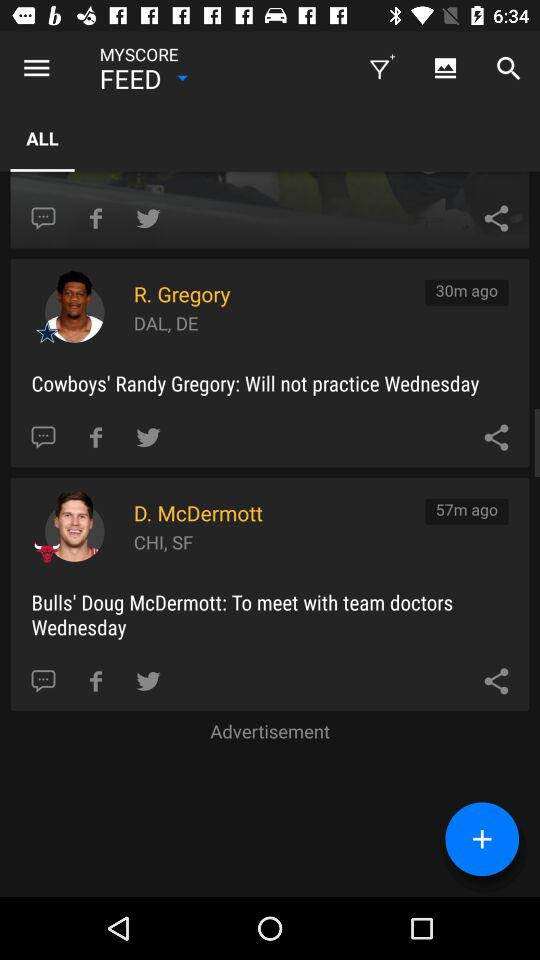What are the teams mentioned in the updates for R. Gregory and D. McDermott? The updates mention that R. Gregory is associated with the Dallas Cowboys, and D. McDermott is with the Chicago Bulls. 